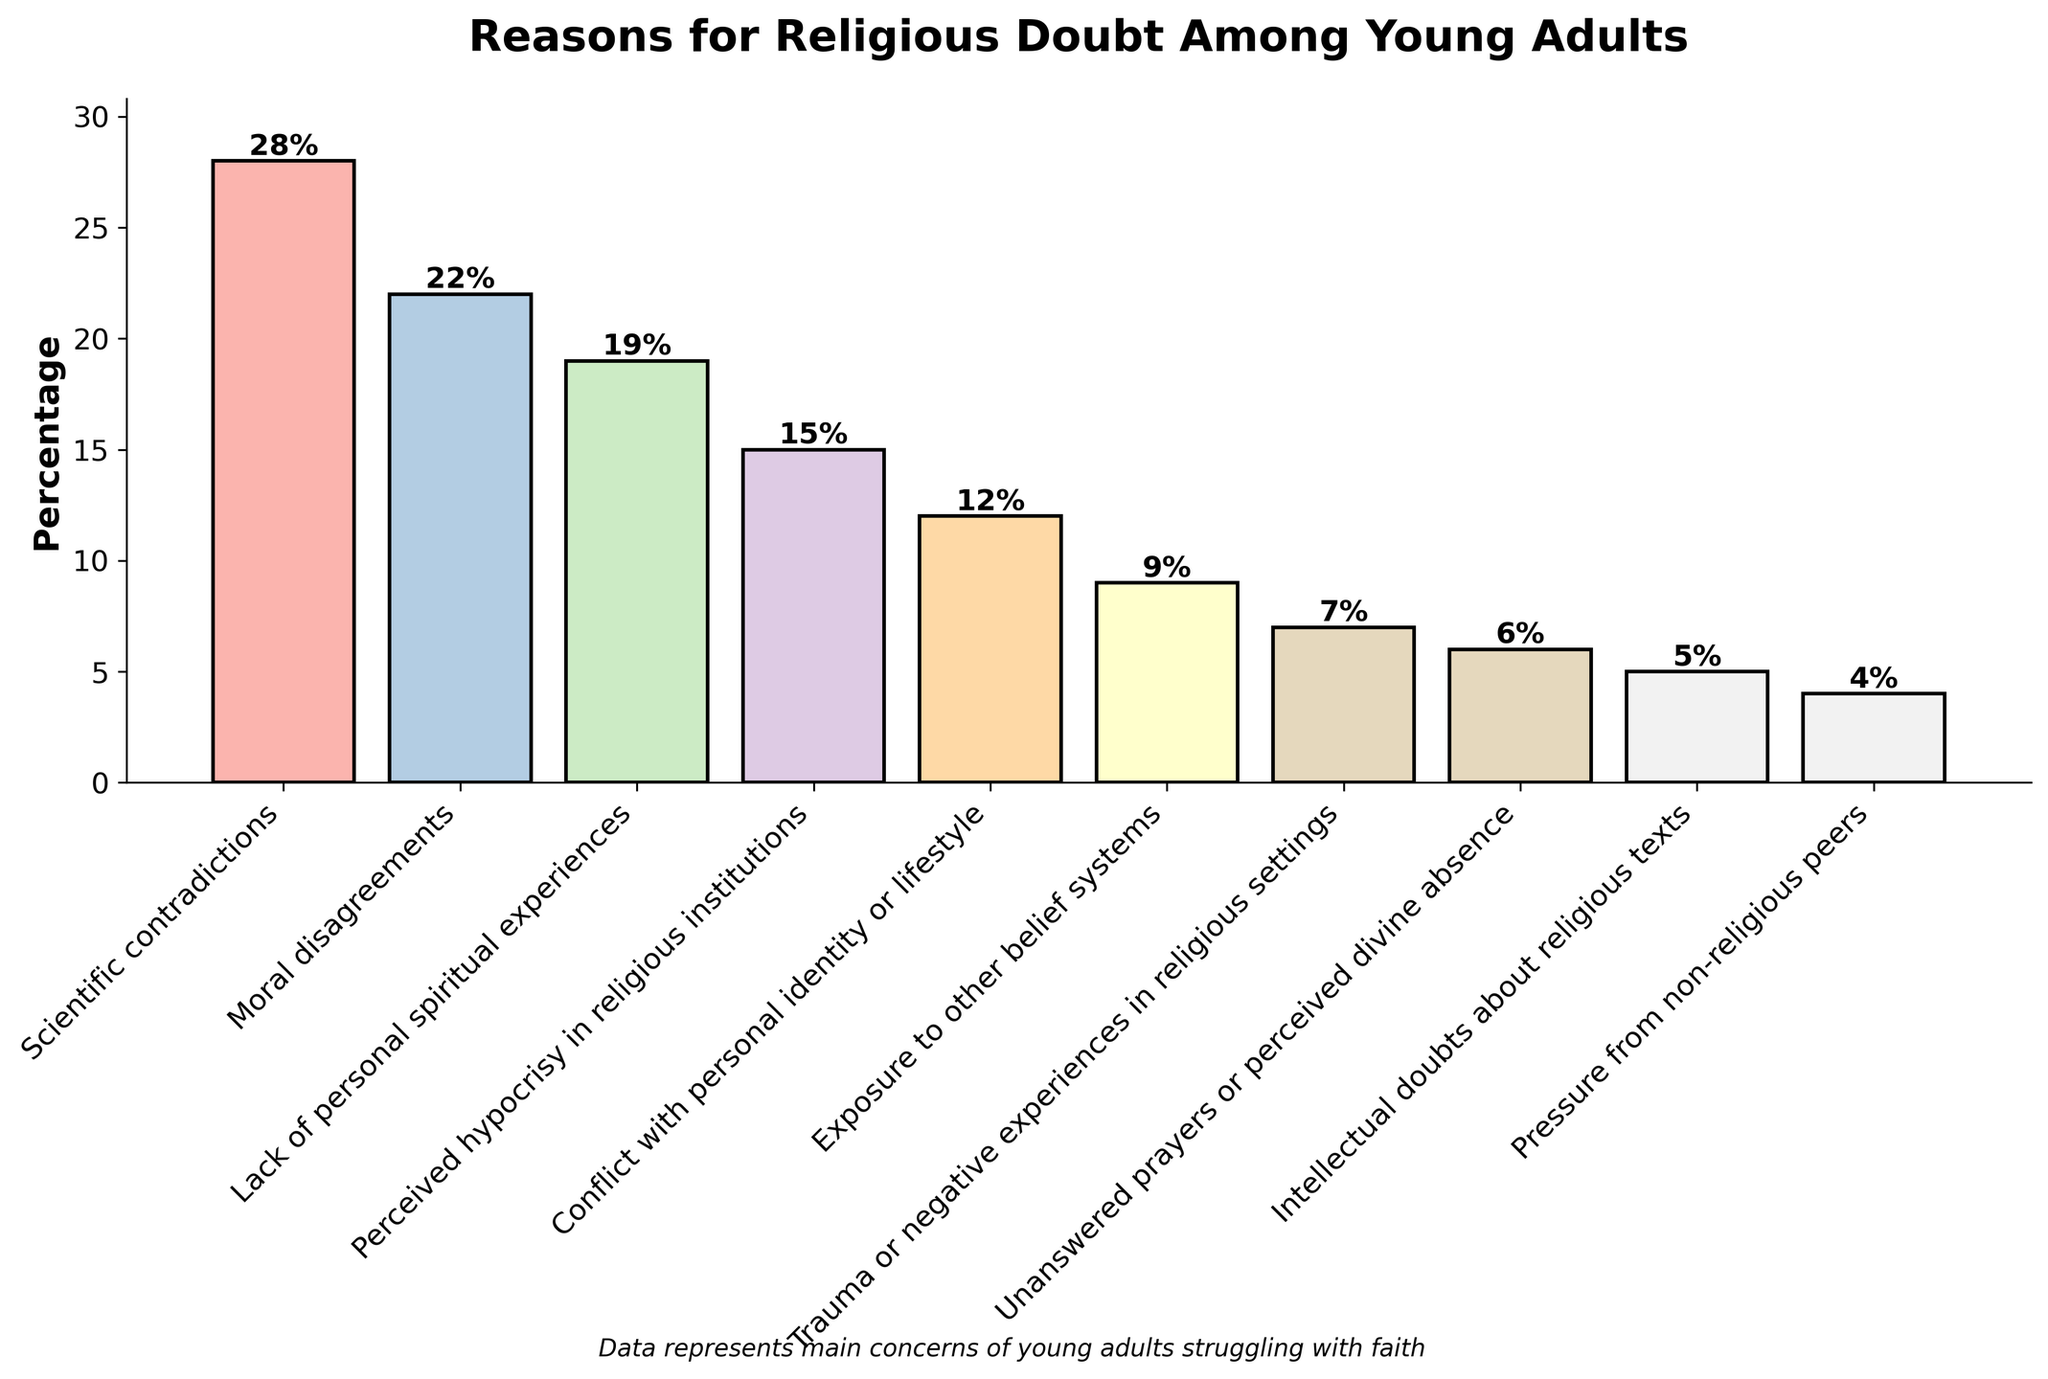What are the top three reasons young adults doubt their religion? The top three reasons, as indicated by the highest bars, are Scientific contradictions (28%), Moral disagreements (22%), and Lack of personal spiritual experiences (19%).
Answer: Scientific contradictions (28%), Moral disagreements (22%), Lack of personal spiritual experiences (19%) Which concern has the lowest percentage? The shortest bar represents Pressure from non-religious peers, with a percentage of 4%.
Answer: Pressure from non-religious peers (4%) What is the total percentage for Moral disagreements and Lack of personal spiritual experiences combined? Sum the percentages of Moral disagreements (22%) and Lack of personal spiritual experiences (19%): 22 + 19 = 41.
Answer: 41% How much higher is the percentage for Perceived hypocrisy in religious institutions compared to Conflict with personal identity or lifestyle? Subtract the percentage of Conflict with personal identity or lifestyle (12%) from Perceived hypocrisy in religious institutions (15%): 15 - 12 = 3.
Answer: 3% Which concern has a higher percentage: Exposure to other belief systems or Unanswered prayers or perceived divine absence? Compare the bars for Exposure to other belief systems (9%) and Unanswered prayers or perceived divine absence (6%); Exposure to other belief systems is higher.
Answer: Exposure to other belief systems (9%) What is the percentage range of the listed concerns? The highest percentage is for Scientific contradictions (28%), and the lowest is for Pressure from non-religious peers (4%). The range is 28 - 4 = 24.
Answer: 24% Which category has a percentage that falls exactly in the middle of all values? Calculate the median percentage of all the data points: The percentages in ascending order are 4%, 5%, 6%, 7%, 9%, 12%, 15%, 19%, 22%, 28%. The median values are the 5th and 6th, averaging 9% and 12%: (9 + 12) / 2 = 10.5%. There is no exact middle value, but both Exposure to other belief systems (9%) and Conflict with personal identity or lifestyle (12%) are close.
Answer: 10.5% What is the difference in percentage between the highest and the lowest concern? Subtract the percentage of the lowest concern (Pressure from non-religious peers, 4%) from the highest concern (Scientific contradictions, 28%): 28 - 4 = 24.
Answer: 24% How does Trauma or negative experiences in religious settings compare to Intellectual doubts about religious texts? Compare the percentages of Trauma or negative experiences in religious settings (7%) and Intellectual doubts about religious texts (5%); Trauma or negative experiences in religious settings is higher.
Answer: Trauma or negative experiences (7%) is higher Which categories have percentages greater than the average percentage across all categories? First calculate the average percentage across all categories: (28 + 22 + 19 + 15 + 12 + 9 + 7 + 6 + 5 + 4) / 10 = 12.7%. Categories with percentages greater than 12.7% are Scientific contradictions, Moral disagreements, Lack of personal spiritual experiences, and Perceived hypocrisy in religious institutions.
Answer: Scientific contradictions, Moral disagreements, Lack of personal spiritual experiences, Perceived hypocrisy in religious institutions 